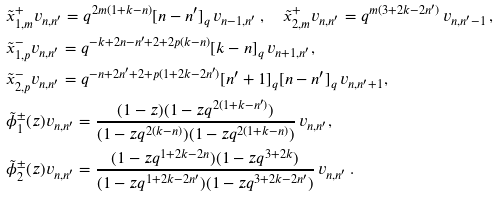<formula> <loc_0><loc_0><loc_500><loc_500>& \tilde { x } _ { 1 , m } ^ { + } v _ { n , n ^ { \prime } } = q ^ { 2 m ( 1 + k - n ) } [ n - n ^ { \prime } ] _ { q } \, v _ { n - 1 , n ^ { \prime } } \, , \quad \tilde { x } _ { 2 , m } ^ { + } v _ { n , n ^ { \prime } } = q ^ { m ( 3 + 2 k - 2 n ^ { \prime } ) } \, v _ { n , n ^ { \prime } - 1 } \, , \\ & \tilde { x } _ { 1 , p } ^ { - } v _ { n , n ^ { \prime } } = q ^ { - k + 2 n - n ^ { \prime } + 2 + 2 p ( k - n ) } [ k - n ] _ { q } \, v _ { n + 1 , n ^ { \prime } } , \\ & \tilde { x } _ { 2 , p } ^ { - } v _ { n , n ^ { \prime } } = q ^ { - n + 2 n ^ { \prime } + 2 + p ( 1 + 2 k - 2 n ^ { \prime } ) } [ n ^ { \prime } + 1 ] _ { q } [ n - n ^ { \prime } ] _ { q } \, v _ { n , n ^ { \prime } + 1 } , \\ & \tilde { \phi } _ { 1 } ^ { \pm } ( z ) v _ { n , n ^ { \prime } } = \frac { ( 1 - z ) ( 1 - z q ^ { 2 ( 1 + k - n ^ { \prime } ) } ) } { ( 1 - z q ^ { 2 ( k - n ) } ) ( 1 - z q ^ { 2 ( 1 + k - n ) } ) } \, v _ { n , n ^ { \prime } } , \\ & \tilde { \phi } _ { 2 } ^ { \pm } ( z ) v _ { n , n ^ { \prime } } = \frac { ( 1 - z q ^ { 1 + 2 k - 2 n } ) ( 1 - z q ^ { 3 + 2 k } ) } { ( 1 - z q ^ { 1 + 2 k - 2 n ^ { \prime } } ) ( 1 - z q ^ { 3 + 2 k - 2 n ^ { \prime } } ) } \, v _ { n , n ^ { \prime } } \, .</formula> 